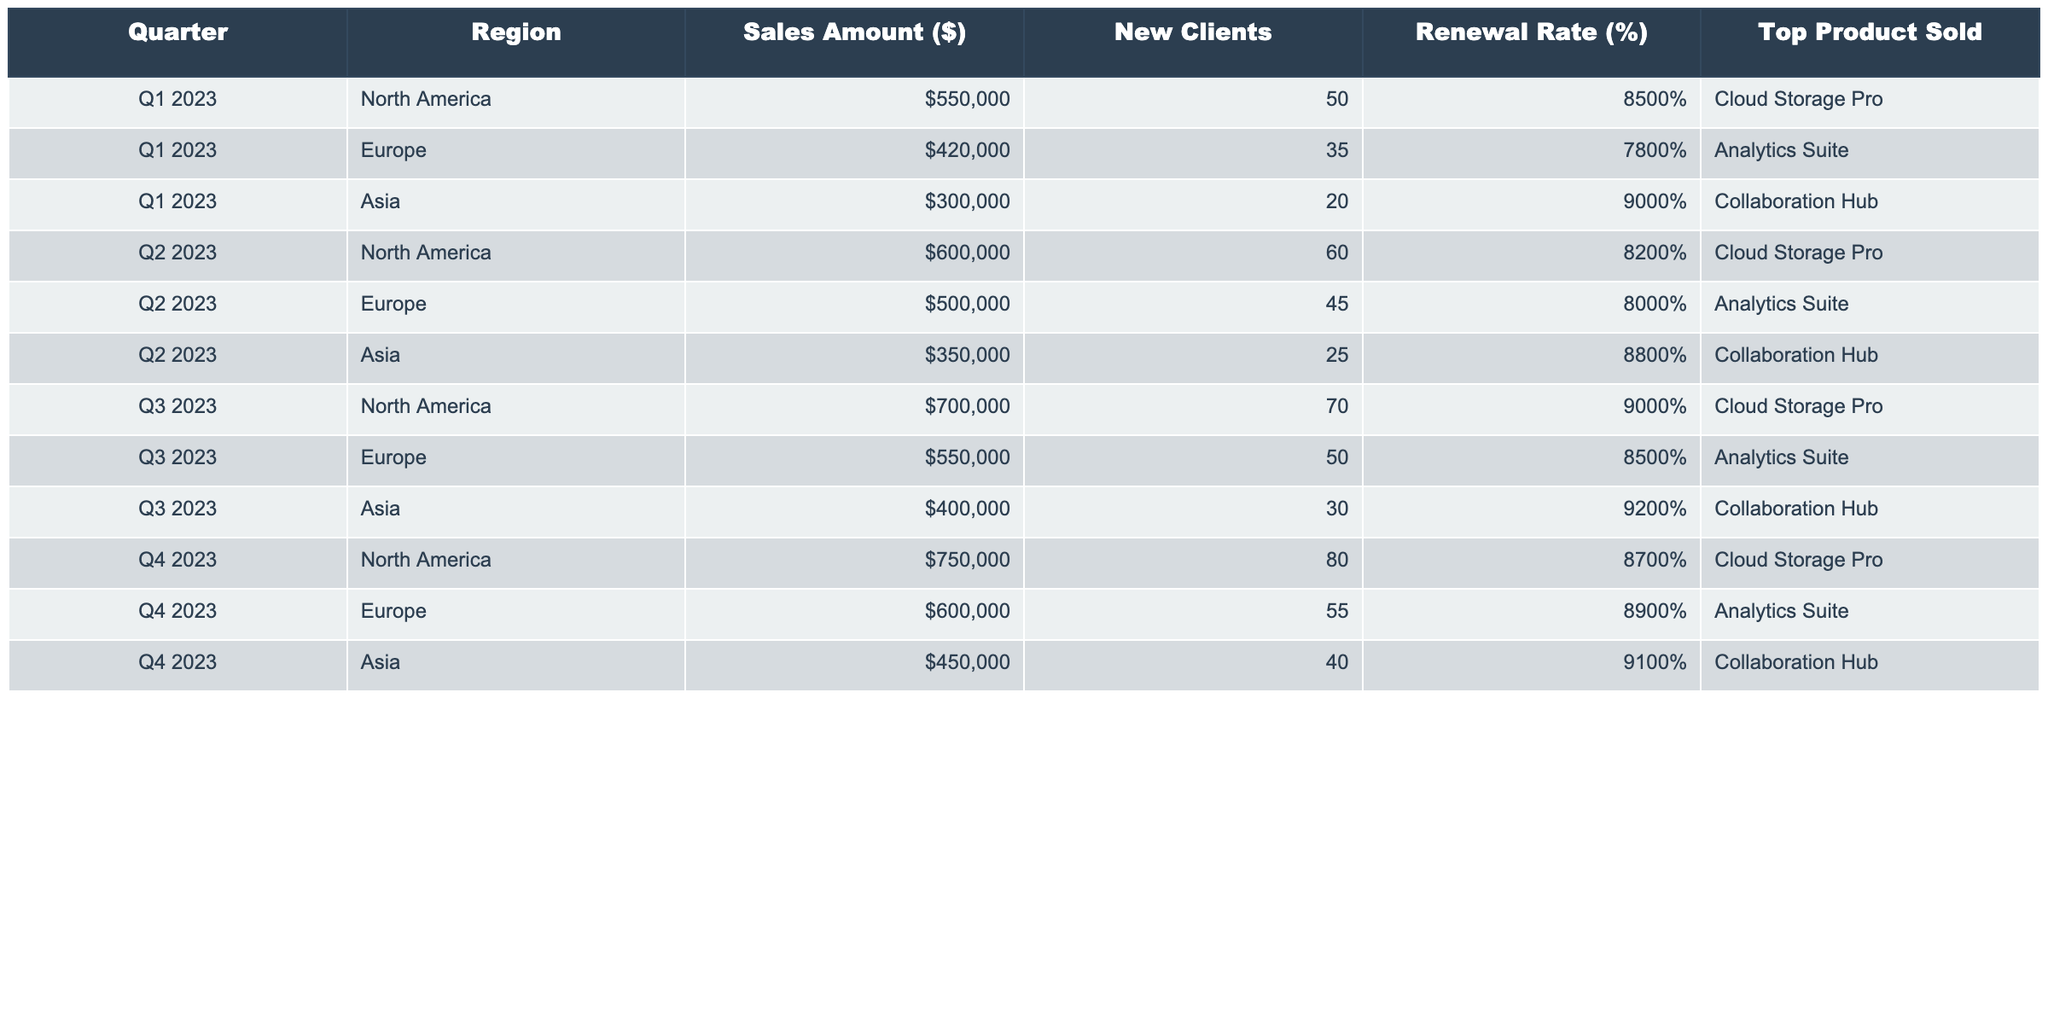What was the total sales amount in Q1 2023? The sales amounts in Q1 2023 are 550000 for North America, 420000 for Europe, and 300000 for Asia. Summing these values gives 550000 + 420000 + 300000 = 1270000.
Answer: 1270000 Which region had the highest renewal rate in Q3 2023? In Q3 2023, the renewal rates are 90% for North America, 85% for Europe, and 92% for Asia. The highest renewal rate is 92% in Asia.
Answer: Asia What is the average number of new clients acquired across all regions in Q4 2023? The new clients in Q4 2023 are 80 for North America, 55 for Europe, and 40 for Asia. The average is (80 + 55 + 40) / 3 = 175 / 3 = 58.33, which rounds to 58.
Answer: 58 Did the sales amount in Asia increase from Q2 2023 to Q4 2023? The sales amount in Asia for Q2 2023 is 350000 and for Q4 2023 it is 450000. Since 450000 > 350000, it indicates an increase.
Answer: Yes What is the total sales amount for North America across all four quarters? The sales amounts for North America in each quarter are 550000 (Q1) + 600000 (Q2) + 700000 (Q3) + 750000 (Q4). Summing these gives 550000 + 600000 + 700000 + 750000 = 2600000.
Answer: 2600000 Which product was the top seller in Europe during Q2 2023? The top product sold in Europe during Q2 2023 is "Analytics Suite," as stated in the table.
Answer: Analytics Suite What was the percentage increase in new clients from Q1 2023 to Q3 2023 in Asia? The new clients in Q1 2023 for Asia are 20 and in Q3 2023 are 30. The increase is 30 - 20 = 10. To find the percentage increase: (10 / 20) x 100% = 50%.
Answer: 50% In which quarter did North America achieve the highest sales amount? The sales amounts for North America are 550000 in Q1, 600000 in Q2, 700000 in Q3, and 750000 in Q4. The highest sales amount, 750000, occurs in Q4 2023.
Answer: Q4 2023 How does the total sales amount in Q2 compare to that in Q3? The total sales amounts are 600000 for North America, 500000 for Europe, and 350000 for Asia in Q2, totaling 600000 + 500000 + 350000 = 1450000. In Q3, the totals are 700000 (NA) + 550000 (EU) + 400000 (AS) = 1650000. Comparing these, 1650000 > 1450000 shows Q3 has higher sales.
Answer: Q3 has higher sales Which region showed the greatest increase in sales from Q1 to Q2 2023? Calculating the sales increase from Q1 to Q2 for each region: North America: 600000 - 550000 = 50000, Europe: 500000 - 420000 = 80000, Asia: 350000 - 300000 = 50000. The greatest increase, 80000, is seen in Europe.
Answer: Europe 